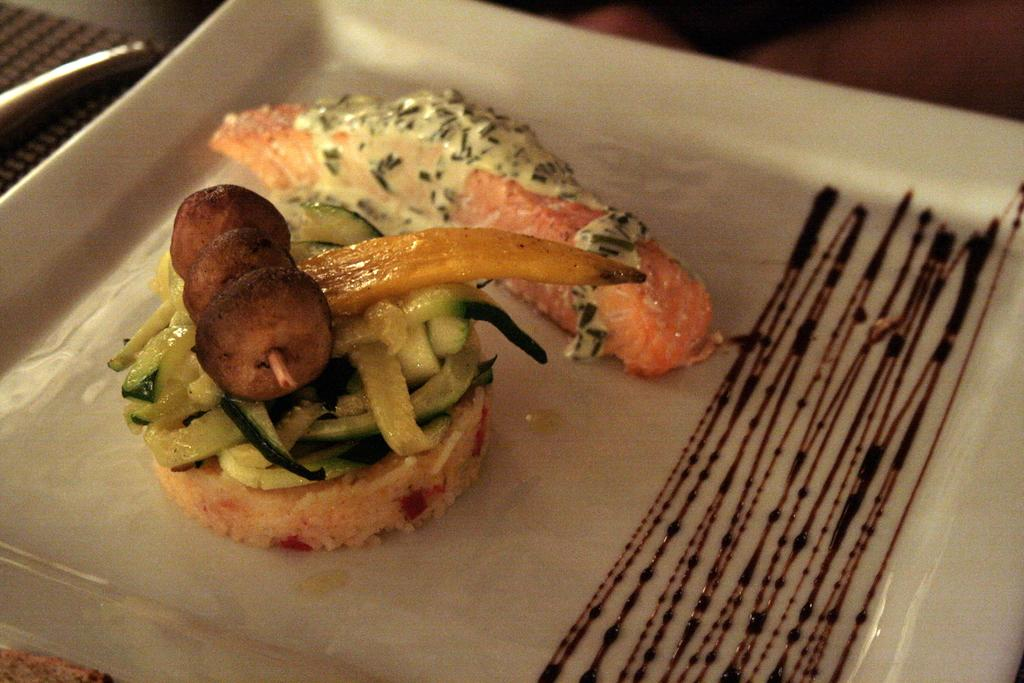What type of furniture is present in the image? There is a table in the image. What is placed on the table? There is a napkin and a plate with a food item on the table. What is the rate at which the finger is moving towards the cakes in the image? There are no cakes or fingers present in the image, so it is not possible to determine the rate at which a finger might be moving towards cakes. 